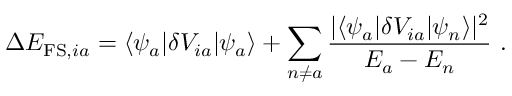<formula> <loc_0><loc_0><loc_500><loc_500>\Delta E _ { F S , i a } = \langle \psi _ { a } | \delta V _ { i a } | \psi _ { a } \rangle + \sum _ { n \neq a } \frac { | \langle \psi _ { a } | \delta V _ { i a } | \psi _ { n } \rangle | ^ { 2 } } { E _ { a } - E _ { n } } \ .</formula> 